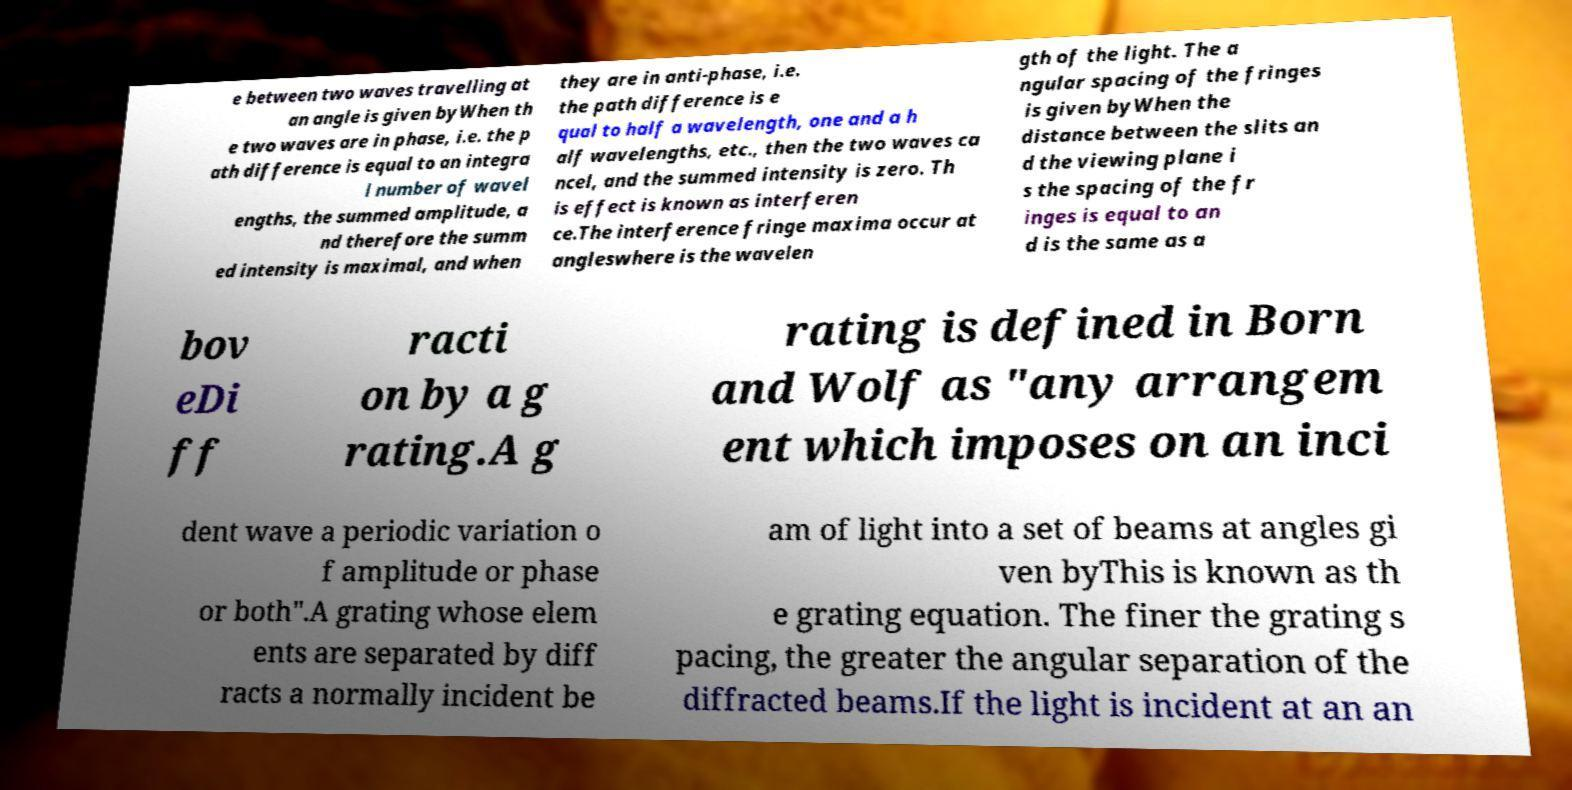For documentation purposes, I need the text within this image transcribed. Could you provide that? e between two waves travelling at an angle is given byWhen th e two waves are in phase, i.e. the p ath difference is equal to an integra l number of wavel engths, the summed amplitude, a nd therefore the summ ed intensity is maximal, and when they are in anti-phase, i.e. the path difference is e qual to half a wavelength, one and a h alf wavelengths, etc., then the two waves ca ncel, and the summed intensity is zero. Th is effect is known as interferen ce.The interference fringe maxima occur at angleswhere is the wavelen gth of the light. The a ngular spacing of the fringes is given byWhen the distance between the slits an d the viewing plane i s the spacing of the fr inges is equal to an d is the same as a bov eDi ff racti on by a g rating.A g rating is defined in Born and Wolf as "any arrangem ent which imposes on an inci dent wave a periodic variation o f amplitude or phase or both".A grating whose elem ents are separated by diff racts a normally incident be am of light into a set of beams at angles gi ven byThis is known as th e grating equation. The finer the grating s pacing, the greater the angular separation of the diffracted beams.If the light is incident at an an 